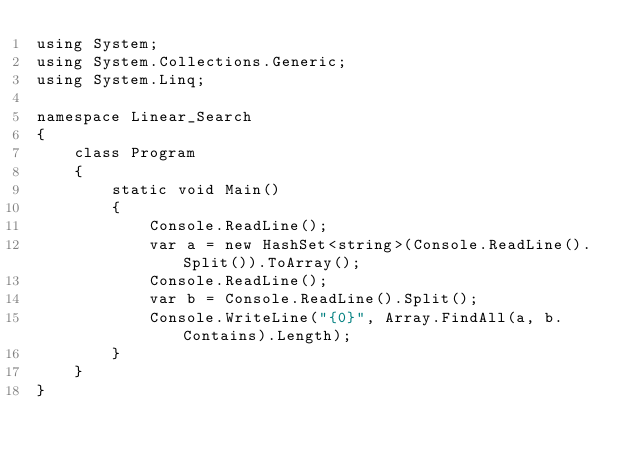Convert code to text. <code><loc_0><loc_0><loc_500><loc_500><_C#_>using System;
using System.Collections.Generic;
using System.Linq;
 
namespace Linear_Search
{
    class Program
    {
        static void Main()
        {
            Console.ReadLine();
            var a = new HashSet<string>(Console.ReadLine().Split()).ToArray();
            Console.ReadLine();
            var b = Console.ReadLine().Split();
            Console.WriteLine("{0}", Array.FindAll(a, b.Contains).Length);
        }
    }
}</code> 